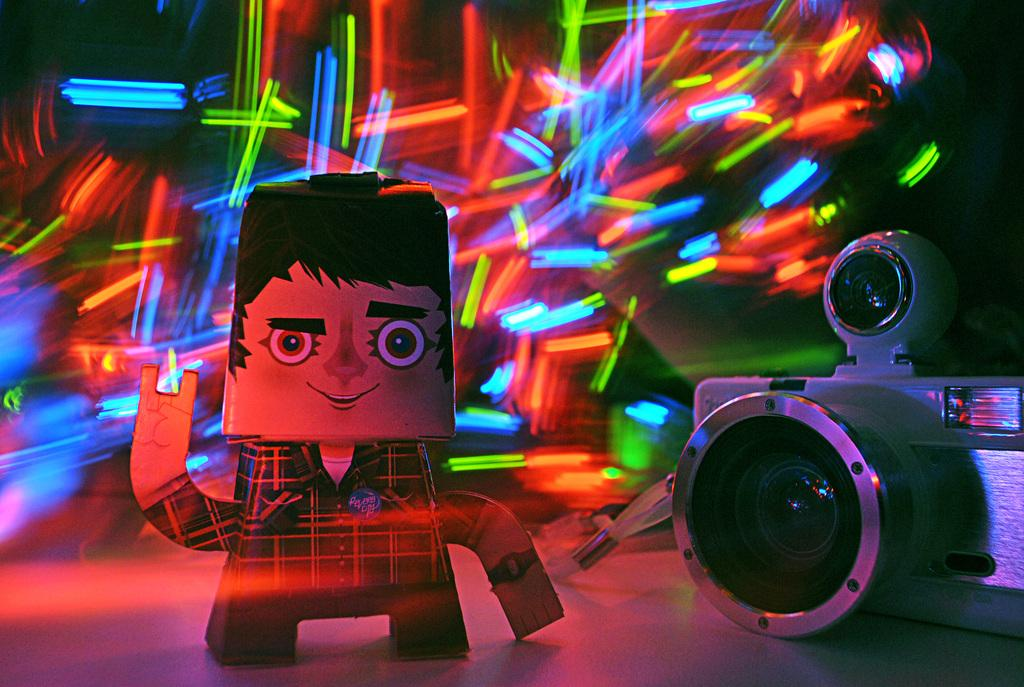What is the main object in the picture? There is a camera in the picture. What other object can be seen in the picture? There is a toy in the picture. What can be seen in the background of the picture? There are lights visible in the background of the picture. What type of tree is visible in the room in the image? There is no tree or room present in the image; it features a camera and a toy with lights in the background. 